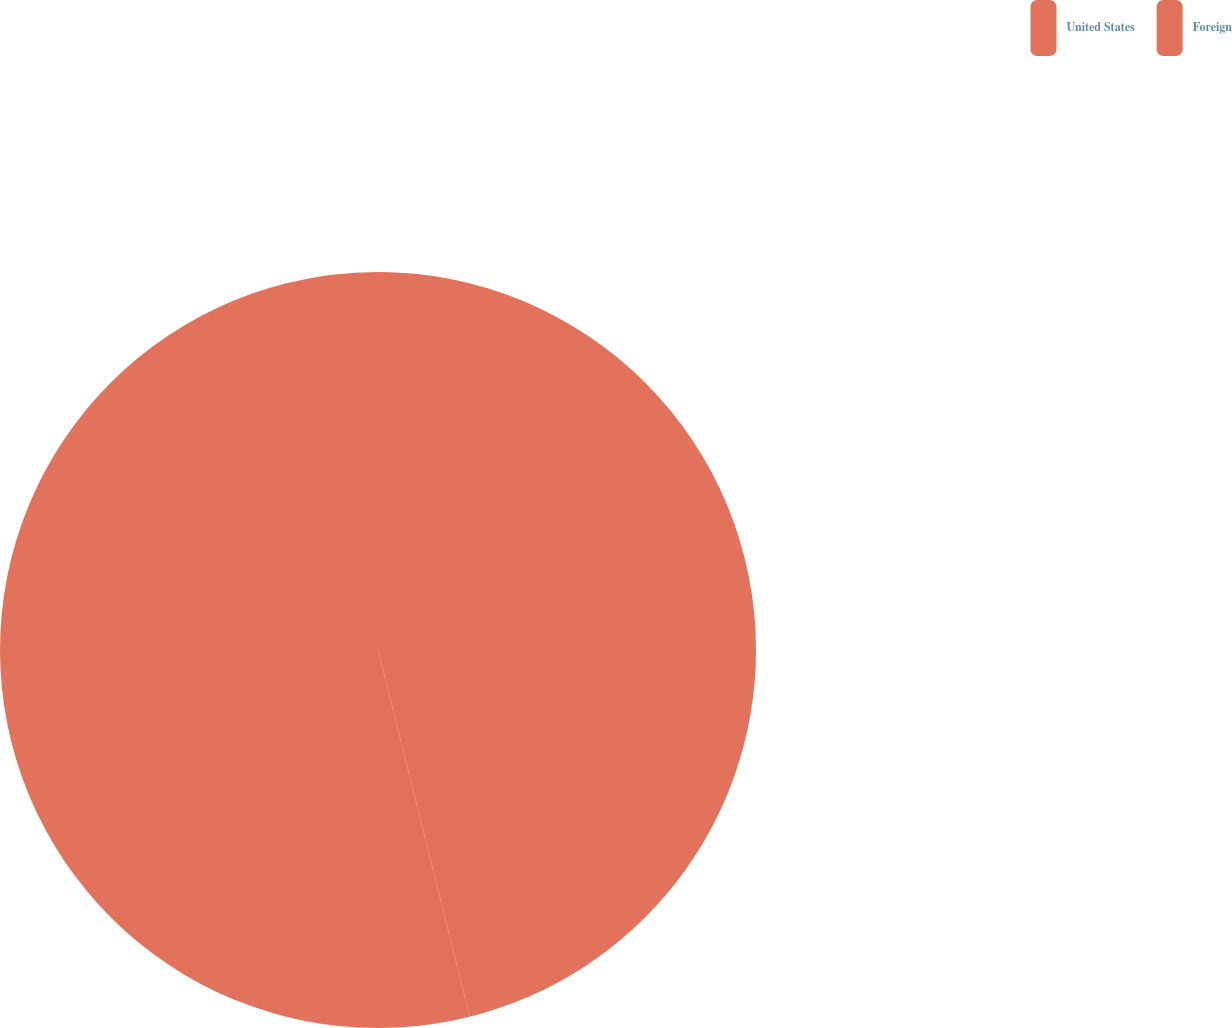Convert chart to OTSL. <chart><loc_0><loc_0><loc_500><loc_500><pie_chart><fcel>United States<fcel>Foreign<nl><fcel>46.1%<fcel>53.9%<nl></chart> 